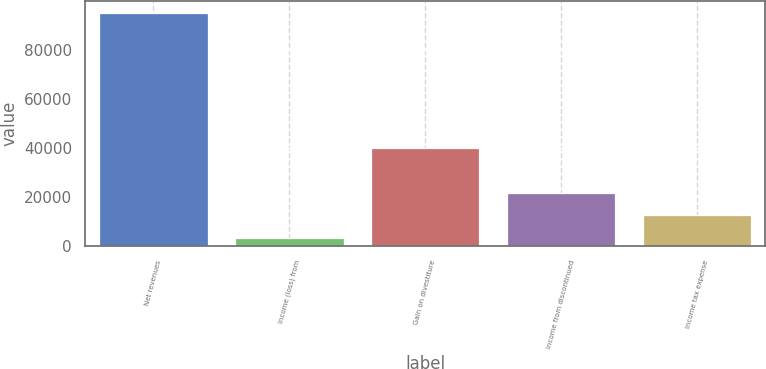<chart> <loc_0><loc_0><loc_500><loc_500><bar_chart><fcel>Net revenues<fcel>Income (loss) from<fcel>Gain on divestiture<fcel>Income from discontinued<fcel>Income tax expense<nl><fcel>95226<fcel>3472<fcel>40173.6<fcel>21822.8<fcel>12647.4<nl></chart> 